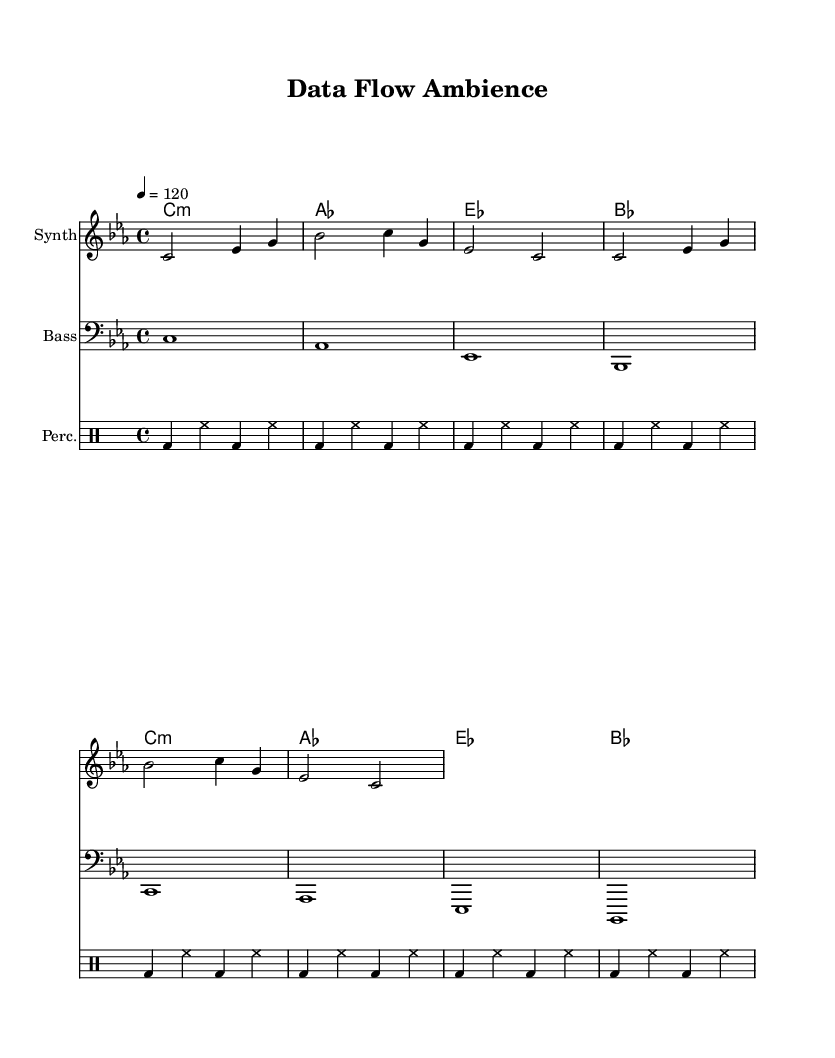What is the key signature of this music? The key signature is C minor, which indicates the presence of three flats (B, E, and A) in the scale.
Answer: C minor What is the time signature of this piece? The time signature is indicated as 4/4, meaning there are four beats in each measure and a quarter note receives one beat.
Answer: 4/4 What is the tempo marking for the piece? The tempo marking is 120 beats per minute, suggesting it has a moderate pace suitable for ambient music.
Answer: 120 How many measures are in the melody? The melody is presented in two sections, each containing four measures, totaling eight measures overall.
Answer: 8 What instrument plays the bass part? The bass part is indicated in the sheet music with a clef specifically for bass instruments, which shows it is played by a bass instrument.
Answer: Bass Which musical element provides the percussive texture in this piece? The drum part (notated in the "DrumStaff") clearly outlines the rhythms that give the track its beat, comprised of bass drums and hi-hats.
Answer: Percussion What is the chord progression used in the harmonies? The chord progression alternates between C minor, A flat major, E flat major, and B flat major, creating a cohesive harmonic backdrop.
Answer: C minor, A flat major, E flat major, B flat major 